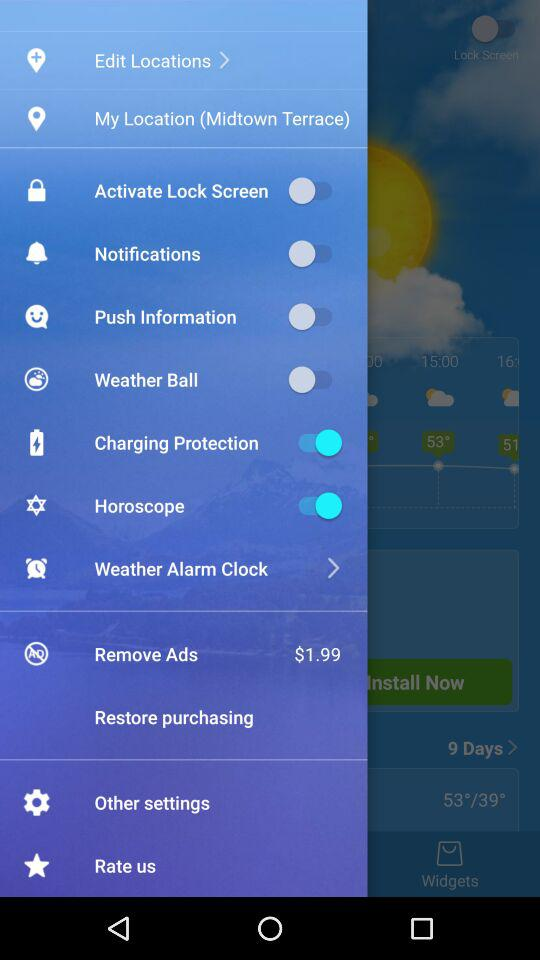What is the status of "Charging Protection"? The status is "on". 